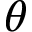Convert formula to latex. <formula><loc_0><loc_0><loc_500><loc_500>\theta</formula> 